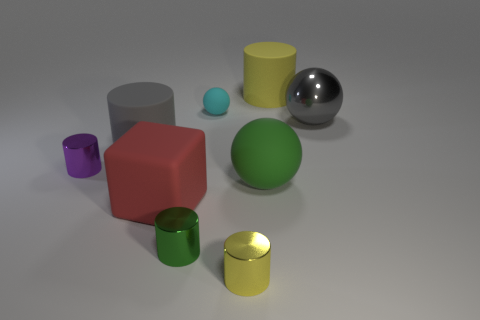What number of things are either cyan matte balls or metallic cylinders that are to the right of the cyan matte ball?
Offer a very short reply. 2. What is the material of the tiny yellow thing?
Keep it short and to the point. Metal. There is another large thing that is the same shape as the big green rubber object; what material is it?
Give a very brief answer. Metal. The thing to the left of the big cylinder that is to the left of the red object is what color?
Give a very brief answer. Purple. What number of shiny things are tiny cyan objects or brown things?
Ensure brevity in your answer.  0. Do the big gray ball and the tiny yellow thing have the same material?
Your answer should be compact. Yes. What material is the big sphere behind the shiny cylinder left of the large rubber block made of?
Provide a short and direct response. Metal. How many tiny things are red rubber objects or gray objects?
Provide a short and direct response. 0. What is the size of the gray cylinder?
Offer a very short reply. Large. Are there more green balls to the right of the small matte object than cyan cylinders?
Offer a very short reply. Yes. 